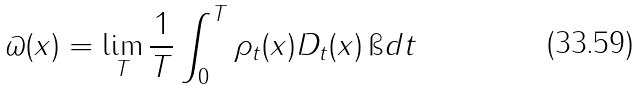Convert formula to latex. <formula><loc_0><loc_0><loc_500><loc_500>\varpi ( x ) = \lim _ { T } \frac { 1 } { T } \int _ { 0 } ^ { T } \rho _ { t } ( x ) D _ { t } ( x ) \, \i d t</formula> 